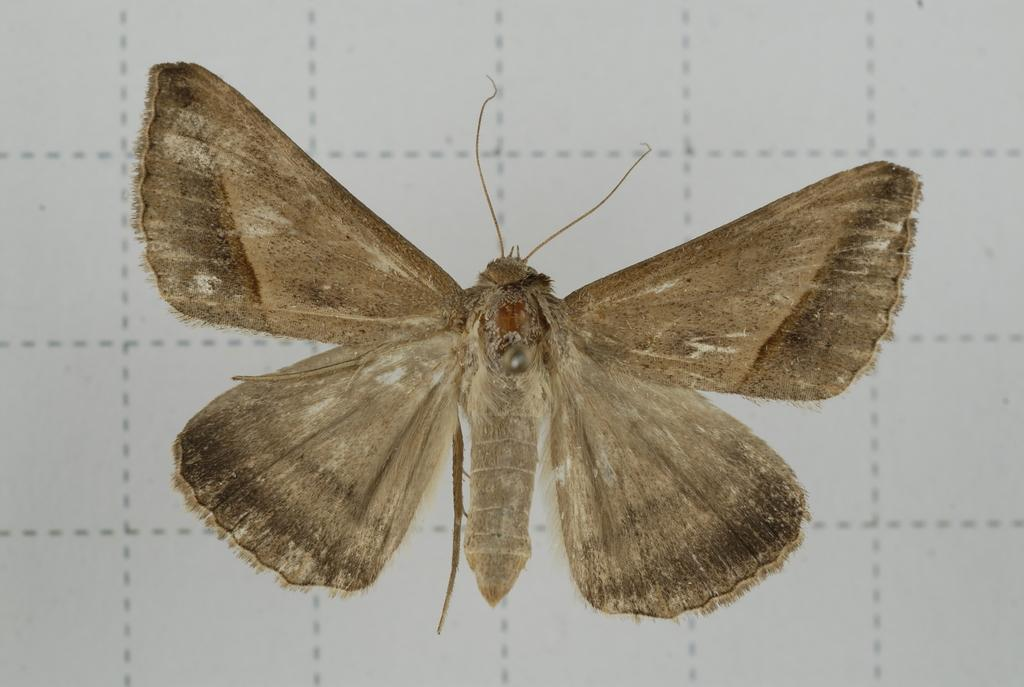What type of insect is present in the image? There is a butterfly in the image. What colors can be seen on the butterfly? The butterfly has brown and black colors. What is the background or surface on which the butterfly is resting? The butterfly is on a white surface. How many passengers are visible in the image? There are no passengers present in the image, as it features a butterfly on a white surface. 